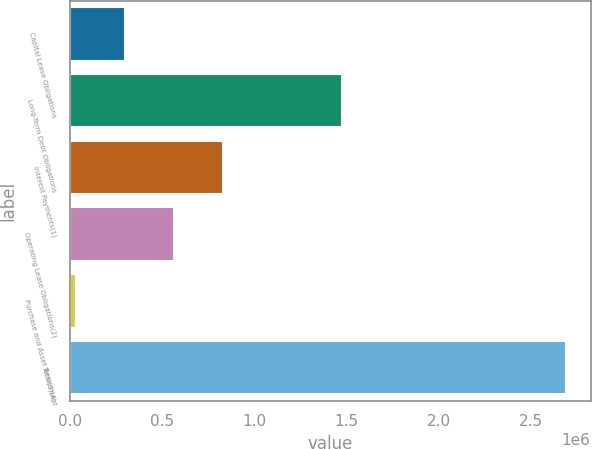Convert chart. <chart><loc_0><loc_0><loc_500><loc_500><bar_chart><fcel>Capital Lease Obligations<fcel>Long-Term Debt Obligations<fcel>Interest Payments(1)<fcel>Operating Lease Obligations(2)<fcel>Purchase and Asset Retirement<fcel>Total(3)(4)<nl><fcel>295913<fcel>1.4719e+06<fcel>827789<fcel>561851<fcel>29975<fcel>2.68935e+06<nl></chart> 